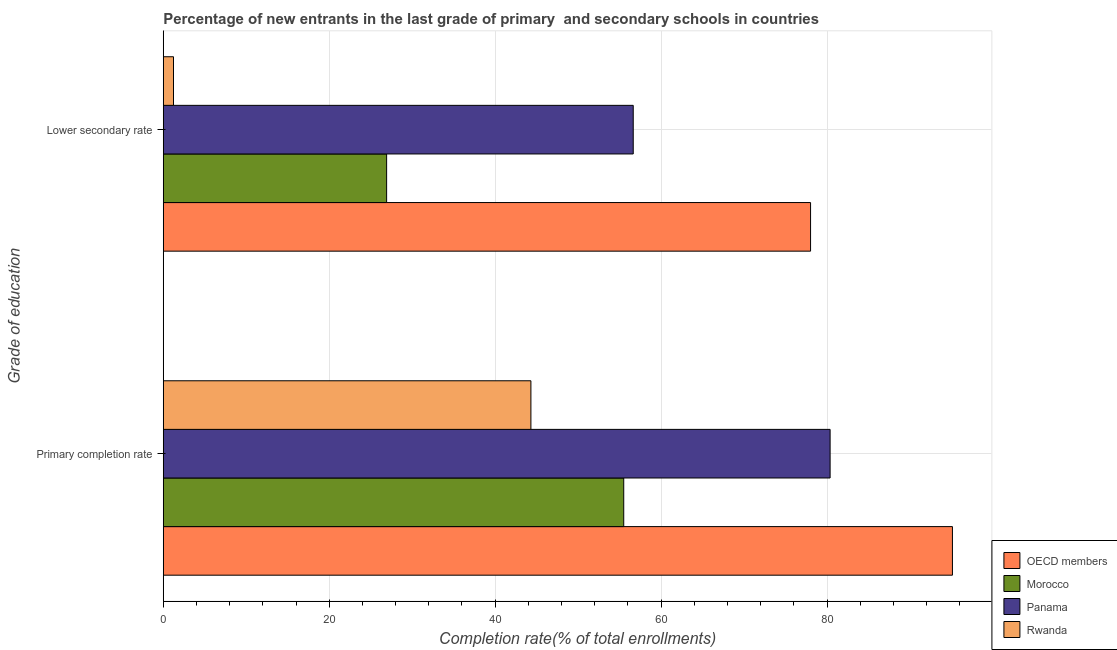Are the number of bars on each tick of the Y-axis equal?
Offer a terse response. Yes. How many bars are there on the 2nd tick from the top?
Offer a very short reply. 4. What is the label of the 2nd group of bars from the top?
Offer a very short reply. Primary completion rate. What is the completion rate in primary schools in Morocco?
Make the answer very short. 55.5. Across all countries, what is the maximum completion rate in secondary schools?
Your answer should be compact. 78.02. Across all countries, what is the minimum completion rate in secondary schools?
Provide a succinct answer. 1.23. In which country was the completion rate in secondary schools minimum?
Offer a terse response. Rwanda. What is the total completion rate in secondary schools in the graph?
Offer a very short reply. 162.82. What is the difference between the completion rate in primary schools in Rwanda and that in Morocco?
Ensure brevity in your answer.  -11.19. What is the difference between the completion rate in secondary schools in Morocco and the completion rate in primary schools in Rwanda?
Make the answer very short. -17.39. What is the average completion rate in primary schools per country?
Your response must be concise. 68.83. What is the difference between the completion rate in primary schools and completion rate in secondary schools in OECD members?
Keep it short and to the point. 17.1. What is the ratio of the completion rate in primary schools in OECD members to that in Morocco?
Make the answer very short. 1.71. Is the completion rate in primary schools in Panama less than that in Rwanda?
Offer a very short reply. No. In how many countries, is the completion rate in primary schools greater than the average completion rate in primary schools taken over all countries?
Your answer should be very brief. 2. What does the 2nd bar from the top in Lower secondary rate represents?
Your answer should be very brief. Panama. What does the 4th bar from the bottom in Primary completion rate represents?
Make the answer very short. Rwanda. How many bars are there?
Make the answer very short. 8. Are all the bars in the graph horizontal?
Give a very brief answer. Yes. Are the values on the major ticks of X-axis written in scientific E-notation?
Offer a terse response. No. How many legend labels are there?
Your answer should be very brief. 4. How are the legend labels stacked?
Your answer should be compact. Vertical. What is the title of the graph?
Give a very brief answer. Percentage of new entrants in the last grade of primary  and secondary schools in countries. What is the label or title of the X-axis?
Offer a terse response. Completion rate(% of total enrollments). What is the label or title of the Y-axis?
Provide a short and direct response. Grade of education. What is the Completion rate(% of total enrollments) of OECD members in Primary completion rate?
Your answer should be compact. 95.12. What is the Completion rate(% of total enrollments) in Morocco in Primary completion rate?
Offer a very short reply. 55.5. What is the Completion rate(% of total enrollments) of Panama in Primary completion rate?
Your answer should be compact. 80.37. What is the Completion rate(% of total enrollments) in Rwanda in Primary completion rate?
Keep it short and to the point. 44.31. What is the Completion rate(% of total enrollments) in OECD members in Lower secondary rate?
Provide a short and direct response. 78.02. What is the Completion rate(% of total enrollments) in Morocco in Lower secondary rate?
Offer a terse response. 26.92. What is the Completion rate(% of total enrollments) in Panama in Lower secondary rate?
Provide a short and direct response. 56.64. What is the Completion rate(% of total enrollments) in Rwanda in Lower secondary rate?
Keep it short and to the point. 1.23. Across all Grade of education, what is the maximum Completion rate(% of total enrollments) in OECD members?
Make the answer very short. 95.12. Across all Grade of education, what is the maximum Completion rate(% of total enrollments) of Morocco?
Your response must be concise. 55.5. Across all Grade of education, what is the maximum Completion rate(% of total enrollments) in Panama?
Your answer should be compact. 80.37. Across all Grade of education, what is the maximum Completion rate(% of total enrollments) in Rwanda?
Offer a terse response. 44.31. Across all Grade of education, what is the minimum Completion rate(% of total enrollments) of OECD members?
Your response must be concise. 78.02. Across all Grade of education, what is the minimum Completion rate(% of total enrollments) of Morocco?
Offer a terse response. 26.92. Across all Grade of education, what is the minimum Completion rate(% of total enrollments) of Panama?
Offer a very short reply. 56.64. Across all Grade of education, what is the minimum Completion rate(% of total enrollments) of Rwanda?
Ensure brevity in your answer.  1.23. What is the total Completion rate(% of total enrollments) in OECD members in the graph?
Offer a very short reply. 173.14. What is the total Completion rate(% of total enrollments) in Morocco in the graph?
Give a very brief answer. 82.42. What is the total Completion rate(% of total enrollments) of Panama in the graph?
Offer a terse response. 137.02. What is the total Completion rate(% of total enrollments) of Rwanda in the graph?
Make the answer very short. 45.54. What is the difference between the Completion rate(% of total enrollments) in OECD members in Primary completion rate and that in Lower secondary rate?
Offer a terse response. 17.1. What is the difference between the Completion rate(% of total enrollments) of Morocco in Primary completion rate and that in Lower secondary rate?
Offer a terse response. 28.58. What is the difference between the Completion rate(% of total enrollments) of Panama in Primary completion rate and that in Lower secondary rate?
Provide a short and direct response. 23.73. What is the difference between the Completion rate(% of total enrollments) of Rwanda in Primary completion rate and that in Lower secondary rate?
Offer a terse response. 43.08. What is the difference between the Completion rate(% of total enrollments) in OECD members in Primary completion rate and the Completion rate(% of total enrollments) in Morocco in Lower secondary rate?
Keep it short and to the point. 68.2. What is the difference between the Completion rate(% of total enrollments) of OECD members in Primary completion rate and the Completion rate(% of total enrollments) of Panama in Lower secondary rate?
Ensure brevity in your answer.  38.47. What is the difference between the Completion rate(% of total enrollments) of OECD members in Primary completion rate and the Completion rate(% of total enrollments) of Rwanda in Lower secondary rate?
Your answer should be very brief. 93.89. What is the difference between the Completion rate(% of total enrollments) in Morocco in Primary completion rate and the Completion rate(% of total enrollments) in Panama in Lower secondary rate?
Your response must be concise. -1.14. What is the difference between the Completion rate(% of total enrollments) in Morocco in Primary completion rate and the Completion rate(% of total enrollments) in Rwanda in Lower secondary rate?
Give a very brief answer. 54.27. What is the difference between the Completion rate(% of total enrollments) in Panama in Primary completion rate and the Completion rate(% of total enrollments) in Rwanda in Lower secondary rate?
Your answer should be very brief. 79.14. What is the average Completion rate(% of total enrollments) in OECD members per Grade of education?
Your answer should be very brief. 86.57. What is the average Completion rate(% of total enrollments) of Morocco per Grade of education?
Provide a short and direct response. 41.21. What is the average Completion rate(% of total enrollments) in Panama per Grade of education?
Provide a short and direct response. 68.51. What is the average Completion rate(% of total enrollments) of Rwanda per Grade of education?
Your answer should be compact. 22.77. What is the difference between the Completion rate(% of total enrollments) of OECD members and Completion rate(% of total enrollments) of Morocco in Primary completion rate?
Offer a very short reply. 39.62. What is the difference between the Completion rate(% of total enrollments) in OECD members and Completion rate(% of total enrollments) in Panama in Primary completion rate?
Your answer should be very brief. 14.74. What is the difference between the Completion rate(% of total enrollments) in OECD members and Completion rate(% of total enrollments) in Rwanda in Primary completion rate?
Offer a terse response. 50.81. What is the difference between the Completion rate(% of total enrollments) of Morocco and Completion rate(% of total enrollments) of Panama in Primary completion rate?
Make the answer very short. -24.87. What is the difference between the Completion rate(% of total enrollments) in Morocco and Completion rate(% of total enrollments) in Rwanda in Primary completion rate?
Provide a short and direct response. 11.19. What is the difference between the Completion rate(% of total enrollments) in Panama and Completion rate(% of total enrollments) in Rwanda in Primary completion rate?
Ensure brevity in your answer.  36.06. What is the difference between the Completion rate(% of total enrollments) of OECD members and Completion rate(% of total enrollments) of Morocco in Lower secondary rate?
Offer a terse response. 51.1. What is the difference between the Completion rate(% of total enrollments) of OECD members and Completion rate(% of total enrollments) of Panama in Lower secondary rate?
Offer a very short reply. 21.37. What is the difference between the Completion rate(% of total enrollments) in OECD members and Completion rate(% of total enrollments) in Rwanda in Lower secondary rate?
Provide a succinct answer. 76.79. What is the difference between the Completion rate(% of total enrollments) of Morocco and Completion rate(% of total enrollments) of Panama in Lower secondary rate?
Keep it short and to the point. -29.72. What is the difference between the Completion rate(% of total enrollments) in Morocco and Completion rate(% of total enrollments) in Rwanda in Lower secondary rate?
Your answer should be compact. 25.69. What is the difference between the Completion rate(% of total enrollments) of Panama and Completion rate(% of total enrollments) of Rwanda in Lower secondary rate?
Offer a terse response. 55.41. What is the ratio of the Completion rate(% of total enrollments) of OECD members in Primary completion rate to that in Lower secondary rate?
Provide a succinct answer. 1.22. What is the ratio of the Completion rate(% of total enrollments) in Morocco in Primary completion rate to that in Lower secondary rate?
Your response must be concise. 2.06. What is the ratio of the Completion rate(% of total enrollments) in Panama in Primary completion rate to that in Lower secondary rate?
Give a very brief answer. 1.42. What is the ratio of the Completion rate(% of total enrollments) of Rwanda in Primary completion rate to that in Lower secondary rate?
Your answer should be very brief. 35.95. What is the difference between the highest and the second highest Completion rate(% of total enrollments) of OECD members?
Provide a short and direct response. 17.1. What is the difference between the highest and the second highest Completion rate(% of total enrollments) of Morocco?
Offer a very short reply. 28.58. What is the difference between the highest and the second highest Completion rate(% of total enrollments) of Panama?
Keep it short and to the point. 23.73. What is the difference between the highest and the second highest Completion rate(% of total enrollments) of Rwanda?
Ensure brevity in your answer.  43.08. What is the difference between the highest and the lowest Completion rate(% of total enrollments) in OECD members?
Your answer should be very brief. 17.1. What is the difference between the highest and the lowest Completion rate(% of total enrollments) in Morocco?
Your answer should be very brief. 28.58. What is the difference between the highest and the lowest Completion rate(% of total enrollments) in Panama?
Make the answer very short. 23.73. What is the difference between the highest and the lowest Completion rate(% of total enrollments) in Rwanda?
Your response must be concise. 43.08. 